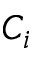<formula> <loc_0><loc_0><loc_500><loc_500>C _ { i }</formula> 